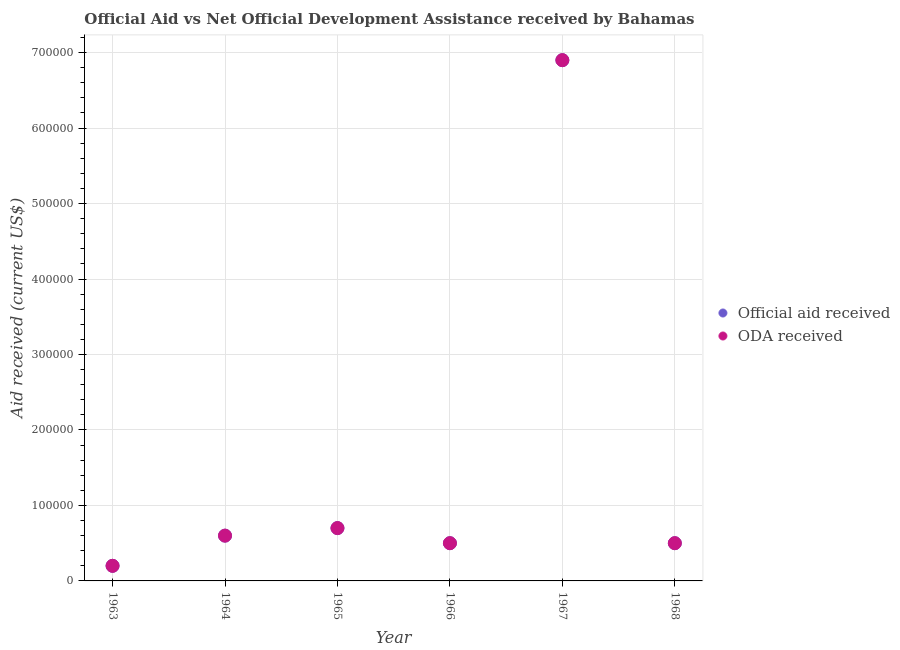How many different coloured dotlines are there?
Provide a succinct answer. 2. What is the official aid received in 1966?
Make the answer very short. 5.00e+04. Across all years, what is the maximum oda received?
Offer a terse response. 6.90e+05. Across all years, what is the minimum official aid received?
Your answer should be compact. 2.00e+04. In which year was the official aid received maximum?
Provide a succinct answer. 1967. What is the total oda received in the graph?
Your response must be concise. 9.40e+05. What is the difference between the official aid received in 1967 and that in 1968?
Offer a very short reply. 6.40e+05. What is the difference between the oda received in 1968 and the official aid received in 1967?
Your answer should be very brief. -6.40e+05. What is the average official aid received per year?
Give a very brief answer. 1.57e+05. In the year 1966, what is the difference between the oda received and official aid received?
Your answer should be very brief. 0. Is the difference between the official aid received in 1964 and 1968 greater than the difference between the oda received in 1964 and 1968?
Make the answer very short. No. What is the difference between the highest and the second highest oda received?
Your answer should be compact. 6.20e+05. What is the difference between the highest and the lowest official aid received?
Your answer should be compact. 6.70e+05. In how many years, is the official aid received greater than the average official aid received taken over all years?
Ensure brevity in your answer.  1. Is the sum of the official aid received in 1963 and 1964 greater than the maximum oda received across all years?
Provide a short and direct response. No. Does the official aid received monotonically increase over the years?
Provide a short and direct response. No. How many dotlines are there?
Provide a short and direct response. 2. What is the difference between two consecutive major ticks on the Y-axis?
Offer a terse response. 1.00e+05. Does the graph contain any zero values?
Make the answer very short. No. How many legend labels are there?
Make the answer very short. 2. What is the title of the graph?
Your answer should be compact. Official Aid vs Net Official Development Assistance received by Bahamas . Does "Short-term debt" appear as one of the legend labels in the graph?
Keep it short and to the point. No. What is the label or title of the X-axis?
Keep it short and to the point. Year. What is the label or title of the Y-axis?
Make the answer very short. Aid received (current US$). What is the Aid received (current US$) of Official aid received in 1964?
Make the answer very short. 6.00e+04. What is the Aid received (current US$) of Official aid received in 1965?
Provide a short and direct response. 7.00e+04. What is the Aid received (current US$) of ODA received in 1965?
Offer a terse response. 7.00e+04. What is the Aid received (current US$) in Official aid received in 1967?
Give a very brief answer. 6.90e+05. What is the Aid received (current US$) in ODA received in 1967?
Offer a very short reply. 6.90e+05. What is the Aid received (current US$) in Official aid received in 1968?
Provide a succinct answer. 5.00e+04. Across all years, what is the maximum Aid received (current US$) of Official aid received?
Provide a succinct answer. 6.90e+05. Across all years, what is the maximum Aid received (current US$) of ODA received?
Provide a succinct answer. 6.90e+05. What is the total Aid received (current US$) of Official aid received in the graph?
Ensure brevity in your answer.  9.40e+05. What is the total Aid received (current US$) of ODA received in the graph?
Ensure brevity in your answer.  9.40e+05. What is the difference between the Aid received (current US$) in ODA received in 1963 and that in 1964?
Ensure brevity in your answer.  -4.00e+04. What is the difference between the Aid received (current US$) in Official aid received in 1963 and that in 1965?
Provide a short and direct response. -5.00e+04. What is the difference between the Aid received (current US$) in Official aid received in 1963 and that in 1966?
Offer a very short reply. -3.00e+04. What is the difference between the Aid received (current US$) of ODA received in 1963 and that in 1966?
Your response must be concise. -3.00e+04. What is the difference between the Aid received (current US$) of Official aid received in 1963 and that in 1967?
Give a very brief answer. -6.70e+05. What is the difference between the Aid received (current US$) in ODA received in 1963 and that in 1967?
Make the answer very short. -6.70e+05. What is the difference between the Aid received (current US$) in ODA received in 1964 and that in 1965?
Your response must be concise. -10000. What is the difference between the Aid received (current US$) in Official aid received in 1964 and that in 1966?
Your response must be concise. 10000. What is the difference between the Aid received (current US$) in ODA received in 1964 and that in 1966?
Give a very brief answer. 10000. What is the difference between the Aid received (current US$) in Official aid received in 1964 and that in 1967?
Offer a very short reply. -6.30e+05. What is the difference between the Aid received (current US$) in ODA received in 1964 and that in 1967?
Keep it short and to the point. -6.30e+05. What is the difference between the Aid received (current US$) of Official aid received in 1964 and that in 1968?
Provide a short and direct response. 10000. What is the difference between the Aid received (current US$) of ODA received in 1965 and that in 1966?
Offer a very short reply. 2.00e+04. What is the difference between the Aid received (current US$) of Official aid received in 1965 and that in 1967?
Ensure brevity in your answer.  -6.20e+05. What is the difference between the Aid received (current US$) in ODA received in 1965 and that in 1967?
Offer a very short reply. -6.20e+05. What is the difference between the Aid received (current US$) in ODA received in 1965 and that in 1968?
Give a very brief answer. 2.00e+04. What is the difference between the Aid received (current US$) in Official aid received in 1966 and that in 1967?
Give a very brief answer. -6.40e+05. What is the difference between the Aid received (current US$) in ODA received in 1966 and that in 1967?
Offer a terse response. -6.40e+05. What is the difference between the Aid received (current US$) in Official aid received in 1966 and that in 1968?
Make the answer very short. 0. What is the difference between the Aid received (current US$) in ODA received in 1966 and that in 1968?
Your answer should be compact. 0. What is the difference between the Aid received (current US$) in Official aid received in 1967 and that in 1968?
Provide a short and direct response. 6.40e+05. What is the difference between the Aid received (current US$) in ODA received in 1967 and that in 1968?
Make the answer very short. 6.40e+05. What is the difference between the Aid received (current US$) of Official aid received in 1963 and the Aid received (current US$) of ODA received in 1966?
Keep it short and to the point. -3.00e+04. What is the difference between the Aid received (current US$) in Official aid received in 1963 and the Aid received (current US$) in ODA received in 1967?
Your answer should be compact. -6.70e+05. What is the difference between the Aid received (current US$) of Official aid received in 1963 and the Aid received (current US$) of ODA received in 1968?
Your response must be concise. -3.00e+04. What is the difference between the Aid received (current US$) in Official aid received in 1964 and the Aid received (current US$) in ODA received in 1966?
Your response must be concise. 10000. What is the difference between the Aid received (current US$) in Official aid received in 1964 and the Aid received (current US$) in ODA received in 1967?
Provide a short and direct response. -6.30e+05. What is the difference between the Aid received (current US$) in Official aid received in 1964 and the Aid received (current US$) in ODA received in 1968?
Make the answer very short. 10000. What is the difference between the Aid received (current US$) of Official aid received in 1965 and the Aid received (current US$) of ODA received in 1967?
Your response must be concise. -6.20e+05. What is the difference between the Aid received (current US$) of Official aid received in 1966 and the Aid received (current US$) of ODA received in 1967?
Your response must be concise. -6.40e+05. What is the difference between the Aid received (current US$) in Official aid received in 1967 and the Aid received (current US$) in ODA received in 1968?
Provide a short and direct response. 6.40e+05. What is the average Aid received (current US$) of Official aid received per year?
Provide a short and direct response. 1.57e+05. What is the average Aid received (current US$) of ODA received per year?
Ensure brevity in your answer.  1.57e+05. In the year 1965, what is the difference between the Aid received (current US$) of Official aid received and Aid received (current US$) of ODA received?
Provide a succinct answer. 0. In the year 1968, what is the difference between the Aid received (current US$) of Official aid received and Aid received (current US$) of ODA received?
Give a very brief answer. 0. What is the ratio of the Aid received (current US$) of Official aid received in 1963 to that in 1964?
Offer a terse response. 0.33. What is the ratio of the Aid received (current US$) of ODA received in 1963 to that in 1964?
Your answer should be compact. 0.33. What is the ratio of the Aid received (current US$) in Official aid received in 1963 to that in 1965?
Your answer should be very brief. 0.29. What is the ratio of the Aid received (current US$) of ODA received in 1963 to that in 1965?
Your answer should be compact. 0.29. What is the ratio of the Aid received (current US$) in ODA received in 1963 to that in 1966?
Ensure brevity in your answer.  0.4. What is the ratio of the Aid received (current US$) in Official aid received in 1963 to that in 1967?
Your answer should be compact. 0.03. What is the ratio of the Aid received (current US$) of ODA received in 1963 to that in 1967?
Your response must be concise. 0.03. What is the ratio of the Aid received (current US$) in Official aid received in 1963 to that in 1968?
Provide a short and direct response. 0.4. What is the ratio of the Aid received (current US$) in ODA received in 1963 to that in 1968?
Your response must be concise. 0.4. What is the ratio of the Aid received (current US$) in Official aid received in 1964 to that in 1965?
Provide a short and direct response. 0.86. What is the ratio of the Aid received (current US$) of ODA received in 1964 to that in 1965?
Your response must be concise. 0.86. What is the ratio of the Aid received (current US$) in Official aid received in 1964 to that in 1966?
Provide a succinct answer. 1.2. What is the ratio of the Aid received (current US$) of ODA received in 1964 to that in 1966?
Your answer should be compact. 1.2. What is the ratio of the Aid received (current US$) of Official aid received in 1964 to that in 1967?
Make the answer very short. 0.09. What is the ratio of the Aid received (current US$) of ODA received in 1964 to that in 1967?
Your answer should be very brief. 0.09. What is the ratio of the Aid received (current US$) of Official aid received in 1964 to that in 1968?
Keep it short and to the point. 1.2. What is the ratio of the Aid received (current US$) in ODA received in 1964 to that in 1968?
Your answer should be very brief. 1.2. What is the ratio of the Aid received (current US$) of ODA received in 1965 to that in 1966?
Ensure brevity in your answer.  1.4. What is the ratio of the Aid received (current US$) in Official aid received in 1965 to that in 1967?
Provide a succinct answer. 0.1. What is the ratio of the Aid received (current US$) in ODA received in 1965 to that in 1967?
Your response must be concise. 0.1. What is the ratio of the Aid received (current US$) of ODA received in 1965 to that in 1968?
Your response must be concise. 1.4. What is the ratio of the Aid received (current US$) of Official aid received in 1966 to that in 1967?
Provide a succinct answer. 0.07. What is the ratio of the Aid received (current US$) of ODA received in 1966 to that in 1967?
Offer a very short reply. 0.07. What is the ratio of the Aid received (current US$) in ODA received in 1966 to that in 1968?
Your response must be concise. 1. What is the ratio of the Aid received (current US$) in Official aid received in 1967 to that in 1968?
Keep it short and to the point. 13.8. What is the ratio of the Aid received (current US$) of ODA received in 1967 to that in 1968?
Offer a terse response. 13.8. What is the difference between the highest and the second highest Aid received (current US$) of Official aid received?
Your response must be concise. 6.20e+05. What is the difference between the highest and the second highest Aid received (current US$) in ODA received?
Ensure brevity in your answer.  6.20e+05. What is the difference between the highest and the lowest Aid received (current US$) of Official aid received?
Provide a short and direct response. 6.70e+05. What is the difference between the highest and the lowest Aid received (current US$) in ODA received?
Give a very brief answer. 6.70e+05. 